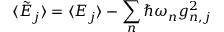<formula> <loc_0><loc_0><loc_500><loc_500>\langle \tilde { E } _ { j } \rangle = \langle E _ { j } \rangle - \sum _ { n } \hbar { \omega } _ { n } g _ { n , j } ^ { 2 }</formula> 